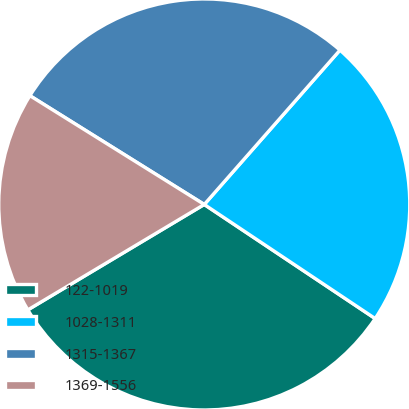Convert chart to OTSL. <chart><loc_0><loc_0><loc_500><loc_500><pie_chart><fcel>122-1019<fcel>1028-1311<fcel>1315-1367<fcel>1369-1556<nl><fcel>32.06%<fcel>22.89%<fcel>27.6%<fcel>17.45%<nl></chart> 